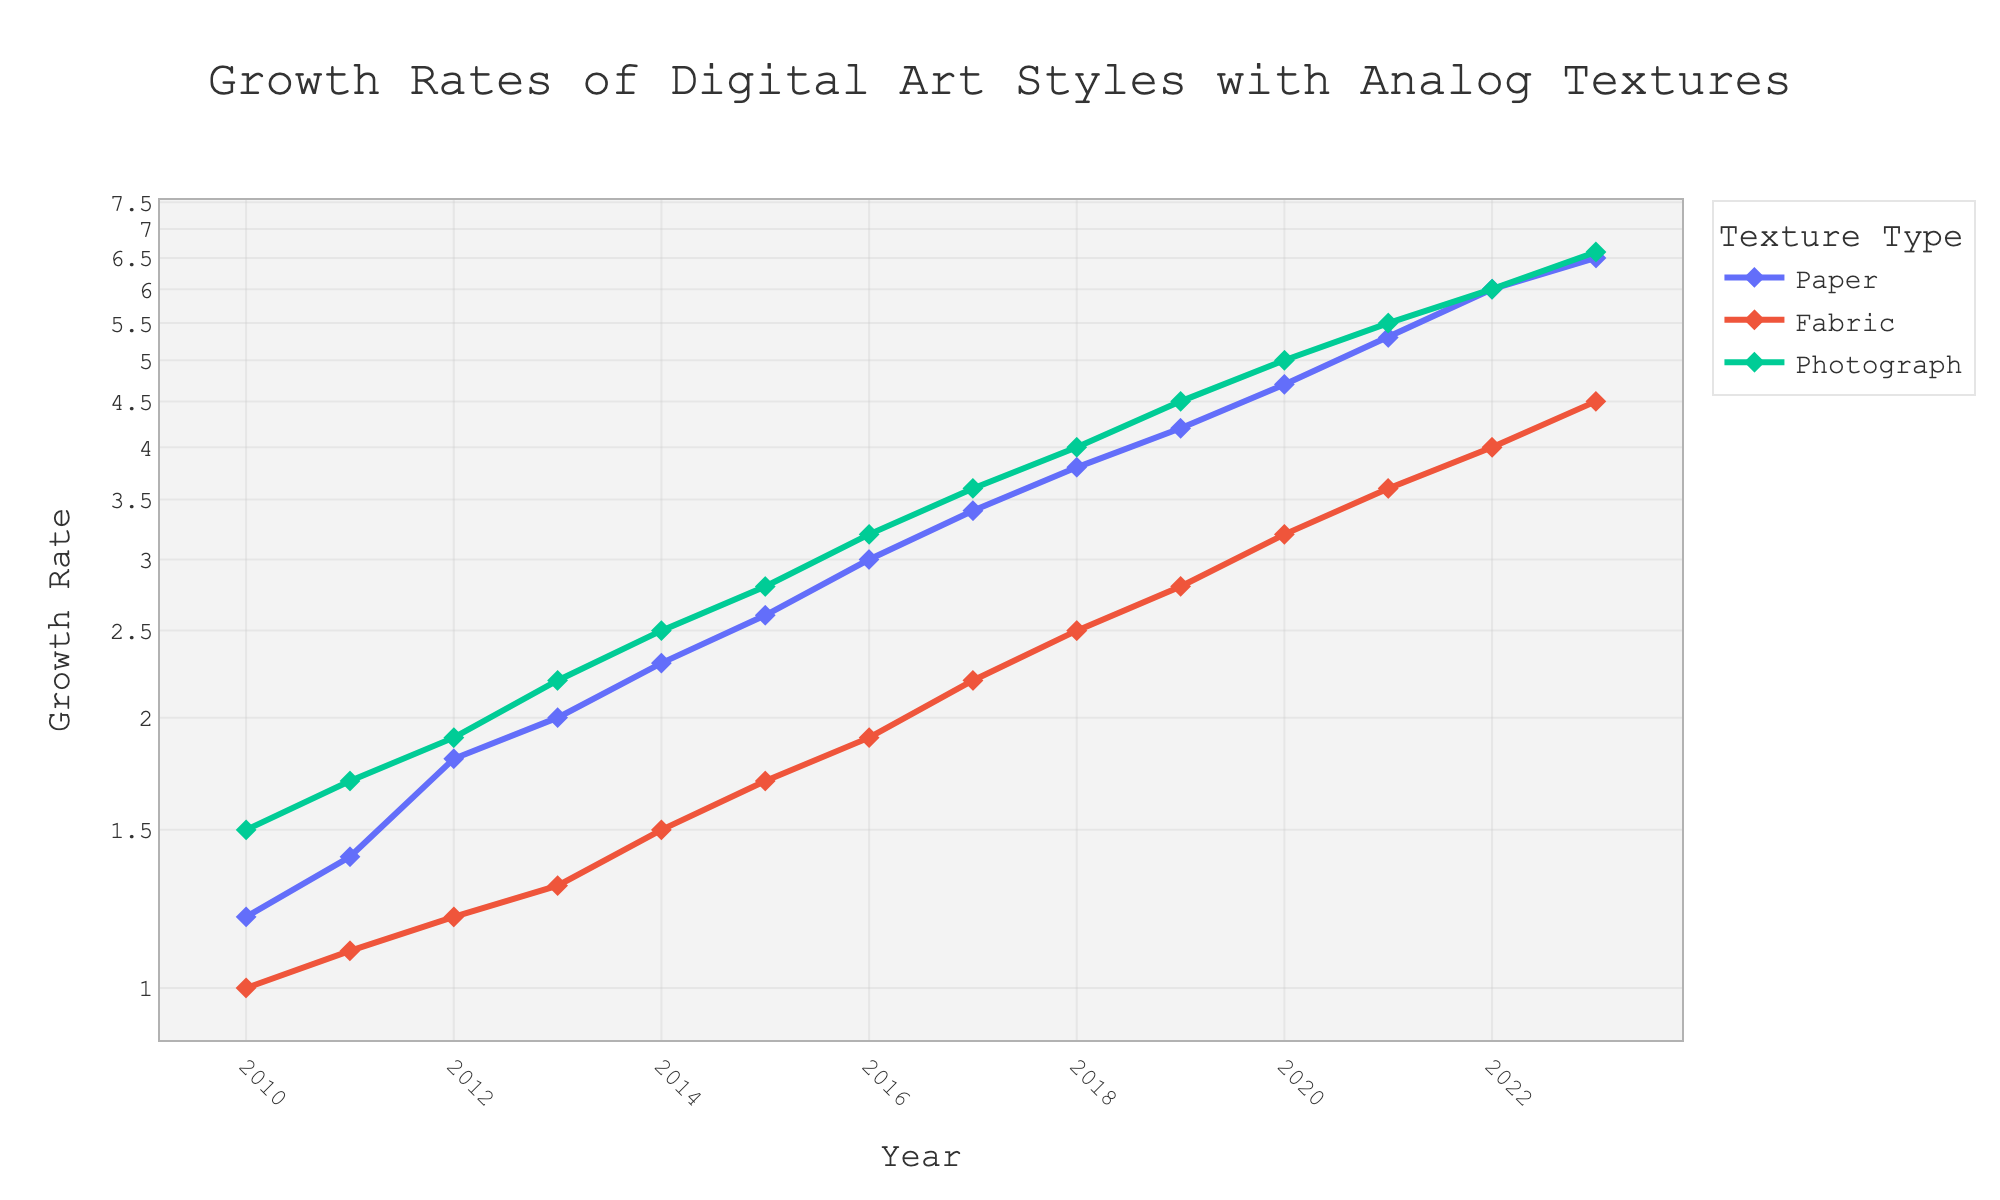What is the title of the plot? The title is the text usually found at the top of a plot, summarizing the main topic of the figure. Here, it appears at the center of the plot's top.
Answer: Growth Rates of Digital Art Styles with Analog Textures Which texture type has the highest growth rate in 2023? To determine this, we need to look at the highest data point for each series in the year 2023. In this case, the Photograph Texture has the highest value at 6.6.
Answer: Photograph Texture How many data points are there for each texture type? Counting the number of markers (each representing a year) for any of the texture types will give this number. There is one data point per year from 2010 to 2023, which is 14 data points for each texture type.
Answer: 14 What is the overall trend of the growth rates for Paper Texture from 2010 to 2023? Observing the log-scaled Y-axis, each year shows a continual increase in the growth rate for Paper Texture. The curve consistently trends upwards.
Answer: Increasing trend In which year did Fabric Texture Growth Rate first surpass 2? By examining the Fabric Texture's trajectory on the Y-axis and finding when it first moves above the value 2. This occurs between 2015-2016.
Answer: 2016 Between which two consecutive years did Photograph Texture see the greatest increase in growth rate? Calculate the year-over-year differences and compare: The largest difference occurs between 2012 (1.9) and 2013 (2.2), which is a difference of 0.3.
Answer: 2012 and 2013 Which texture type shows the least growth rate changes throughout the years? By visual comparison of the three lines, the least steep slope indicates the slowest and least significant changes. The Fabric Texture has the gentlest slope among the three.
Answer: Fabric Texture What is the approximate growth rate of Paper Texture in 2015? Find the year 2015 on the X-axis and trace it vertically to match it with the Paper Texture's growth rate on the Y-axis. The value next to the 2015 mark for Paper Texture is approximately 2.6.
Answer: 2.6 By how much did the growth rate of Paper Texture increase from 2020 to 2023? Subtract the 2020 value (4.7) from the 2023 value (6.5) for Paper Texture: 6.5 - 4.7 = 1.8.
Answer: 1.8 Which year shows the maximum difference between Paper and Fabric Texture Growth Rate? Deduct the Fabric's growth rates from Paper's year by year; identify the year with the highest difference. For instance, in 2023, the difference is 2.0 (6.5 - 4.5), which is the highest.
Answer: 2023 